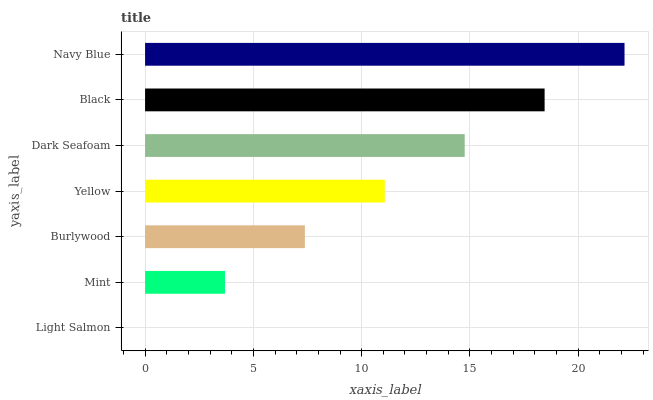Is Light Salmon the minimum?
Answer yes or no. Yes. Is Navy Blue the maximum?
Answer yes or no. Yes. Is Mint the minimum?
Answer yes or no. No. Is Mint the maximum?
Answer yes or no. No. Is Mint greater than Light Salmon?
Answer yes or no. Yes. Is Light Salmon less than Mint?
Answer yes or no. Yes. Is Light Salmon greater than Mint?
Answer yes or no. No. Is Mint less than Light Salmon?
Answer yes or no. No. Is Yellow the high median?
Answer yes or no. Yes. Is Yellow the low median?
Answer yes or no. Yes. Is Mint the high median?
Answer yes or no. No. Is Dark Seafoam the low median?
Answer yes or no. No. 